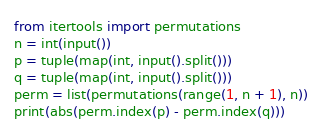Convert code to text. <code><loc_0><loc_0><loc_500><loc_500><_Python_>from itertools import permutations
n = int(input())
p = tuple(map(int, input().split()))
q = tuple(map(int, input().split()))
perm = list(permutations(range(1, n + 1), n))
print(abs(perm.index(p) - perm.index(q)))</code> 